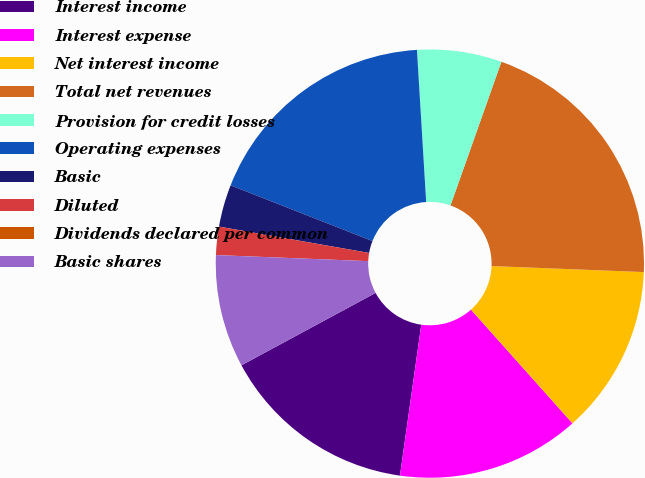Convert chart to OTSL. <chart><loc_0><loc_0><loc_500><loc_500><pie_chart><fcel>Interest income<fcel>Interest expense<fcel>Net interest income<fcel>Total net revenues<fcel>Provision for credit losses<fcel>Operating expenses<fcel>Basic<fcel>Diluted<fcel>Dividends declared per common<fcel>Basic shares<nl><fcel>14.89%<fcel>13.83%<fcel>12.77%<fcel>20.21%<fcel>6.38%<fcel>18.08%<fcel>3.19%<fcel>2.13%<fcel>0.0%<fcel>8.51%<nl></chart> 